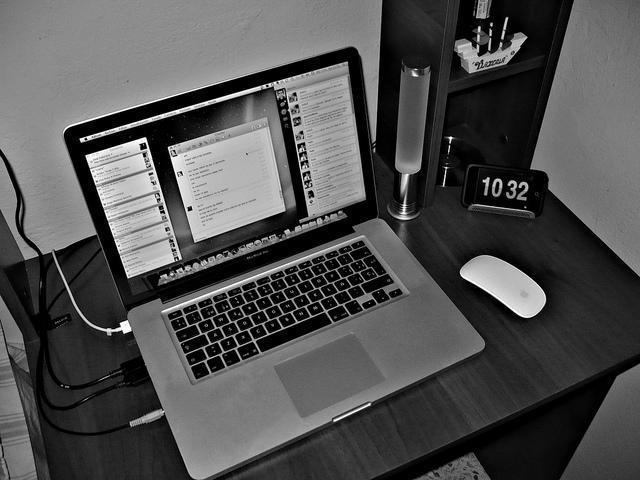How many surfaces does this desk have?
Give a very brief answer. 1. How many laptops can be seen?
Give a very brief answer. 1. How many levels doe the bus have?
Give a very brief answer. 0. 